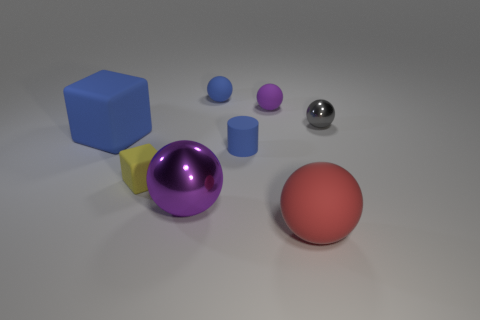There is a metal sphere that is behind the large sphere behind the large red matte sphere; what is its size?
Ensure brevity in your answer.  Small. What is the material of the blue object that is behind the tiny rubber cylinder and in front of the blue matte sphere?
Keep it short and to the point. Rubber. How many other objects are there of the same size as the yellow matte object?
Offer a terse response. 4. The small cylinder is what color?
Ensure brevity in your answer.  Blue. Do the big object to the left of the yellow cube and the rubber sphere that is to the left of the blue matte cylinder have the same color?
Your answer should be compact. Yes. What is the size of the purple rubber object?
Give a very brief answer. Small. What is the size of the blue rubber thing behind the tiny gray thing?
Your response must be concise. Small. There is a tiny rubber thing that is both in front of the big blue rubber cube and on the right side of the large purple object; what is its shape?
Your answer should be very brief. Cylinder. What number of other objects are there of the same shape as the gray thing?
Your response must be concise. 4. What color is the cylinder that is the same size as the yellow matte cube?
Make the answer very short. Blue. 